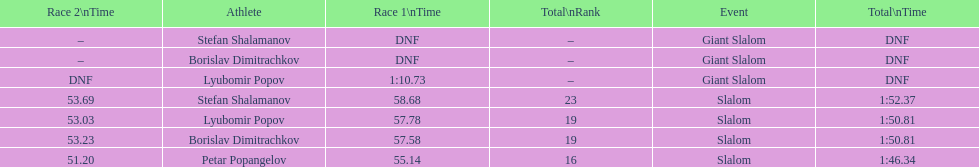How long did it take for lyubomir popov to finish the giant slalom in race 1? 1:10.73. 